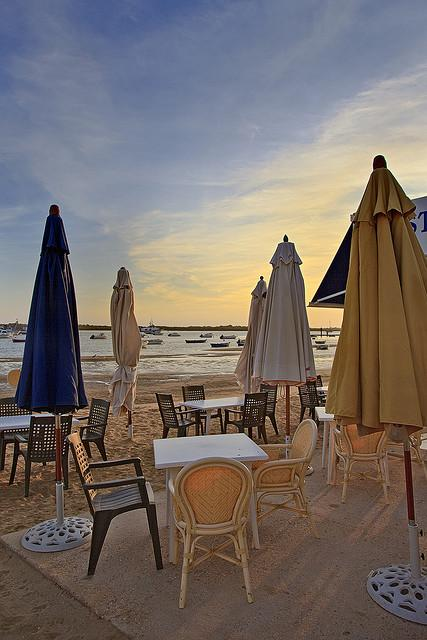What is near the table? chairs 